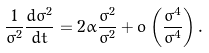Convert formula to latex. <formula><loc_0><loc_0><loc_500><loc_500>\frac { 1 } { \sigma ^ { 2 } } \frac { d \varsigma ^ { 2 } } { d t } = 2 \alpha \frac { \varsigma ^ { 2 } } { \sigma ^ { 2 } } + o \left ( \frac { \varsigma ^ { 4 } } { \sigma ^ { 4 } } \right ) .</formula> 